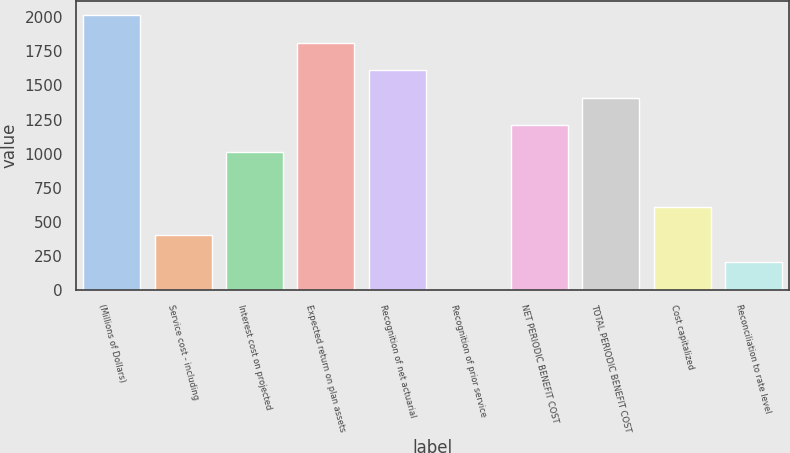Convert chart to OTSL. <chart><loc_0><loc_0><loc_500><loc_500><bar_chart><fcel>(Millions of Dollars)<fcel>Service cost - including<fcel>Interest cost on projected<fcel>Expected return on plan assets<fcel>Recognition of net actuarial<fcel>Recognition of prior service<fcel>NET PERIODIC BENEFIT COST<fcel>TOTAL PERIODIC BENEFIT COST<fcel>Cost capitalized<fcel>Reconciliation to rate level<nl><fcel>2015<fcel>406.2<fcel>1009.5<fcel>1813.9<fcel>1612.8<fcel>4<fcel>1210.6<fcel>1411.7<fcel>607.3<fcel>205.1<nl></chart> 